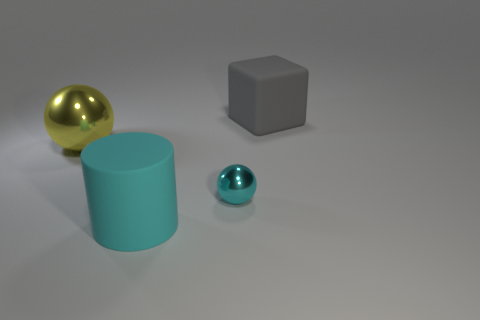Add 3 large cylinders. How many objects exist? 7 Subtract all cubes. How many objects are left? 3 Add 1 cylinders. How many cylinders exist? 2 Subtract 0 brown blocks. How many objects are left? 4 Subtract all big cyan cylinders. Subtract all large cyan things. How many objects are left? 2 Add 3 shiny objects. How many shiny objects are left? 5 